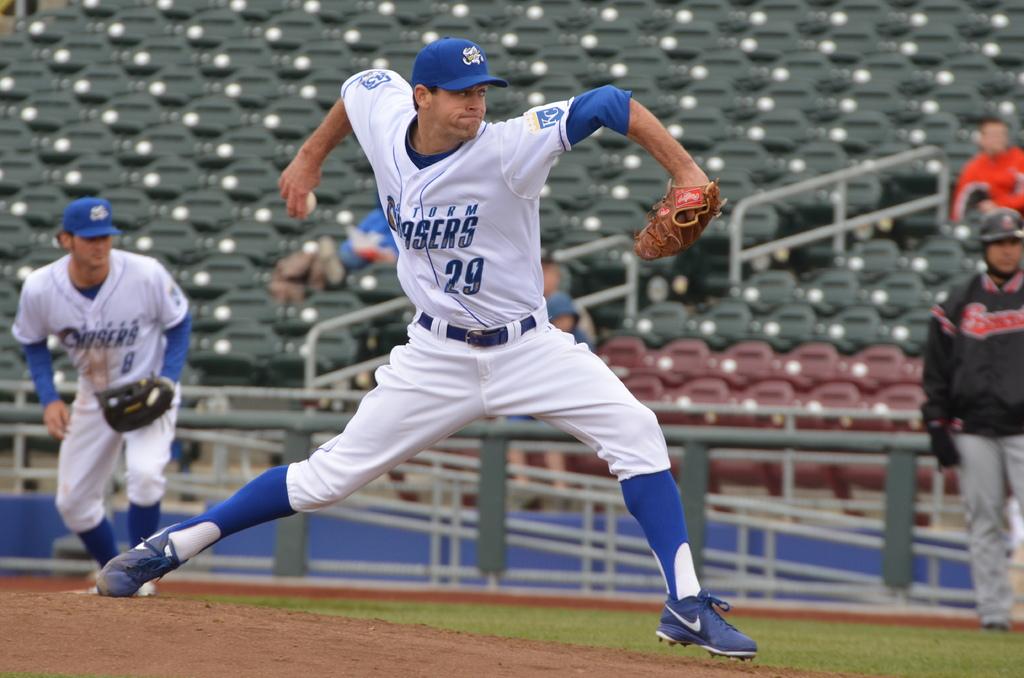What team is the pitcher playing for ?
Your answer should be compact. Storm chasers. What number is the pitcher?
Provide a succinct answer. 29. 